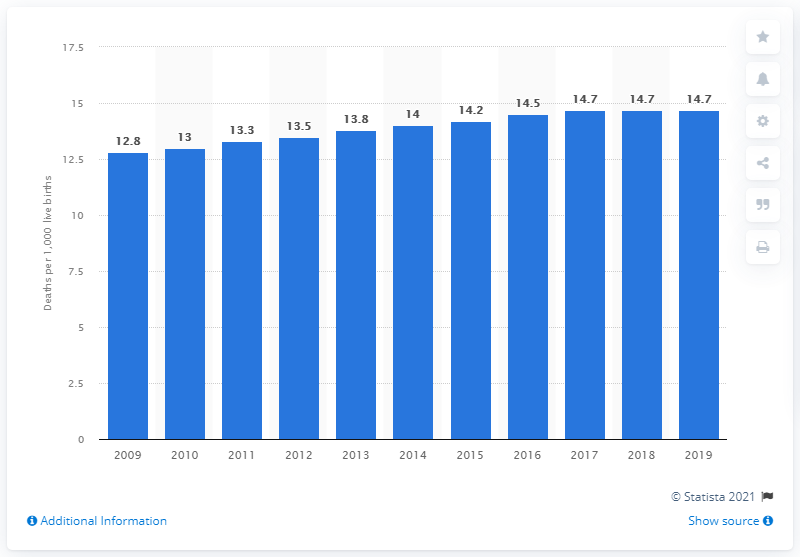Give some essential details in this illustration. In 2019, the infant mortality rate in Grenada was 14.7 deaths per 1,000 live births. 